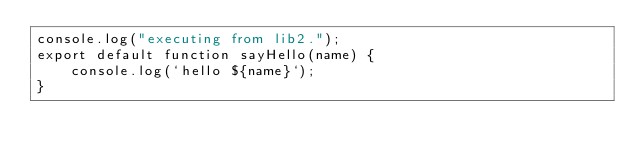<code> <loc_0><loc_0><loc_500><loc_500><_JavaScript_>console.log("executing from lib2.");
export default function sayHello(name) {
    console.log(`hello ${name}`);
}</code> 